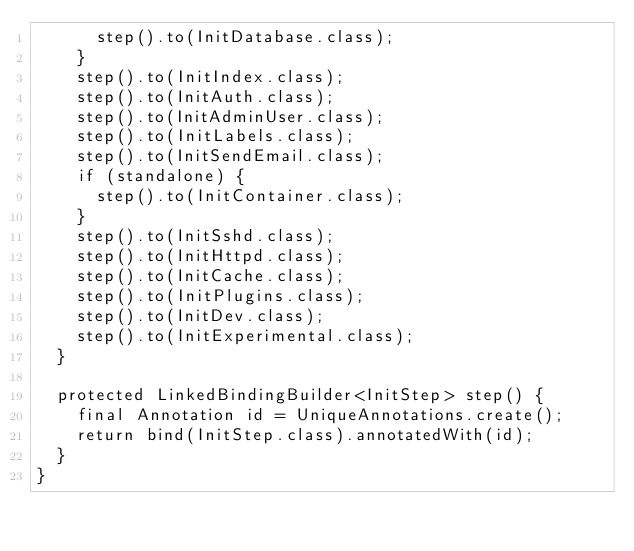<code> <loc_0><loc_0><loc_500><loc_500><_Java_>      step().to(InitDatabase.class);
    }
    step().to(InitIndex.class);
    step().to(InitAuth.class);
    step().to(InitAdminUser.class);
    step().to(InitLabels.class);
    step().to(InitSendEmail.class);
    if (standalone) {
      step().to(InitContainer.class);
    }
    step().to(InitSshd.class);
    step().to(InitHttpd.class);
    step().to(InitCache.class);
    step().to(InitPlugins.class);
    step().to(InitDev.class);
    step().to(InitExperimental.class);
  }

  protected LinkedBindingBuilder<InitStep> step() {
    final Annotation id = UniqueAnnotations.create();
    return bind(InitStep.class).annotatedWith(id);
  }
}
</code> 